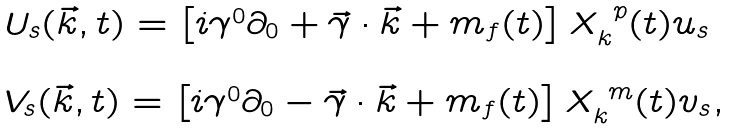<formula> <loc_0><loc_0><loc_500><loc_500>\begin{array} { l } U _ { s } ( \vec { k } , t ) = \left [ i \gamma ^ { 0 } \partial _ { 0 } + \vec { \gamma } \cdot \vec { k } + m _ { f } ( t ) \right ] X _ { k } ^ { \ p } ( t ) u _ { s } \\ \\ V _ { s } ( \vec { k } , t ) = \left [ i \gamma ^ { 0 } \partial _ { 0 } - \vec { \gamma } \cdot \vec { k } + m _ { f } ( t ) \right ] X _ { k } ^ { \ m } ( t ) v _ { s } , \end{array}</formula> 